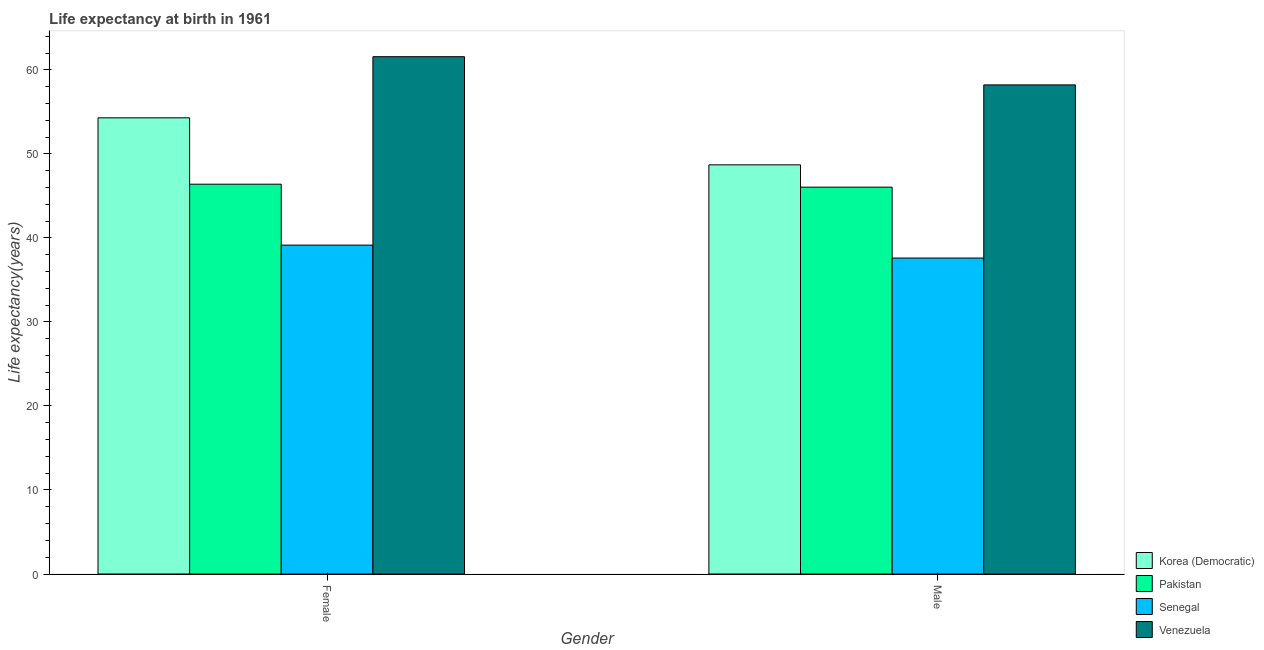Are the number of bars on each tick of the X-axis equal?
Your answer should be compact. Yes. How many bars are there on the 1st tick from the left?
Ensure brevity in your answer.  4. What is the life expectancy(male) in Pakistan?
Keep it short and to the point. 46.05. Across all countries, what is the maximum life expectancy(male)?
Make the answer very short. 58.23. Across all countries, what is the minimum life expectancy(male)?
Your response must be concise. 37.61. In which country was the life expectancy(female) maximum?
Your answer should be very brief. Venezuela. In which country was the life expectancy(female) minimum?
Make the answer very short. Senegal. What is the total life expectancy(female) in the graph?
Your answer should be very brief. 201.44. What is the difference between the life expectancy(male) in Pakistan and that in Senegal?
Make the answer very short. 8.44. What is the difference between the life expectancy(male) in Korea (Democratic) and the life expectancy(female) in Pakistan?
Give a very brief answer. 2.3. What is the average life expectancy(male) per country?
Offer a terse response. 47.65. What is the difference between the life expectancy(female) and life expectancy(male) in Korea (Democratic)?
Your response must be concise. 5.6. What is the ratio of the life expectancy(female) in Pakistan to that in Senegal?
Offer a very short reply. 1.19. Is the life expectancy(male) in Venezuela less than that in Pakistan?
Provide a succinct answer. No. In how many countries, is the life expectancy(female) greater than the average life expectancy(female) taken over all countries?
Your answer should be compact. 2. How many bars are there?
Offer a very short reply. 8. Are all the bars in the graph horizontal?
Your answer should be compact. No. How many countries are there in the graph?
Provide a succinct answer. 4. Are the values on the major ticks of Y-axis written in scientific E-notation?
Give a very brief answer. No. Where does the legend appear in the graph?
Offer a terse response. Bottom right. How are the legend labels stacked?
Provide a succinct answer. Vertical. What is the title of the graph?
Keep it short and to the point. Life expectancy at birth in 1961. What is the label or title of the X-axis?
Make the answer very short. Gender. What is the label or title of the Y-axis?
Your response must be concise. Life expectancy(years). What is the Life expectancy(years) of Korea (Democratic) in Female?
Give a very brief answer. 54.3. What is the Life expectancy(years) of Pakistan in Female?
Keep it short and to the point. 46.4. What is the Life expectancy(years) in Senegal in Female?
Give a very brief answer. 39.15. What is the Life expectancy(years) of Venezuela in Female?
Provide a short and direct response. 61.58. What is the Life expectancy(years) in Korea (Democratic) in Male?
Your response must be concise. 48.71. What is the Life expectancy(years) of Pakistan in Male?
Ensure brevity in your answer.  46.05. What is the Life expectancy(years) of Senegal in Male?
Your answer should be very brief. 37.61. What is the Life expectancy(years) in Venezuela in Male?
Keep it short and to the point. 58.23. Across all Gender, what is the maximum Life expectancy(years) in Korea (Democratic)?
Keep it short and to the point. 54.3. Across all Gender, what is the maximum Life expectancy(years) of Pakistan?
Give a very brief answer. 46.4. Across all Gender, what is the maximum Life expectancy(years) in Senegal?
Offer a very short reply. 39.15. Across all Gender, what is the maximum Life expectancy(years) in Venezuela?
Offer a terse response. 61.58. Across all Gender, what is the minimum Life expectancy(years) in Korea (Democratic)?
Give a very brief answer. 48.71. Across all Gender, what is the minimum Life expectancy(years) in Pakistan?
Provide a short and direct response. 46.05. Across all Gender, what is the minimum Life expectancy(years) in Senegal?
Provide a succinct answer. 37.61. Across all Gender, what is the minimum Life expectancy(years) of Venezuela?
Give a very brief answer. 58.23. What is the total Life expectancy(years) in Korea (Democratic) in the graph?
Your answer should be very brief. 103.01. What is the total Life expectancy(years) in Pakistan in the graph?
Your answer should be compact. 92.45. What is the total Life expectancy(years) in Senegal in the graph?
Provide a short and direct response. 76.76. What is the total Life expectancy(years) of Venezuela in the graph?
Provide a short and direct response. 119.81. What is the difference between the Life expectancy(years) in Korea (Democratic) in Female and that in Male?
Provide a succinct answer. 5.6. What is the difference between the Life expectancy(years) of Pakistan in Female and that in Male?
Provide a short and direct response. 0.35. What is the difference between the Life expectancy(years) of Senegal in Female and that in Male?
Your answer should be very brief. 1.54. What is the difference between the Life expectancy(years) in Venezuela in Female and that in Male?
Your answer should be compact. 3.36. What is the difference between the Life expectancy(years) of Korea (Democratic) in Female and the Life expectancy(years) of Pakistan in Male?
Offer a very short reply. 8.25. What is the difference between the Life expectancy(years) of Korea (Democratic) in Female and the Life expectancy(years) of Senegal in Male?
Your response must be concise. 16.69. What is the difference between the Life expectancy(years) of Korea (Democratic) in Female and the Life expectancy(years) of Venezuela in Male?
Offer a very short reply. -3.92. What is the difference between the Life expectancy(years) in Pakistan in Female and the Life expectancy(years) in Senegal in Male?
Your response must be concise. 8.79. What is the difference between the Life expectancy(years) in Pakistan in Female and the Life expectancy(years) in Venezuela in Male?
Your answer should be compact. -11.82. What is the difference between the Life expectancy(years) of Senegal in Female and the Life expectancy(years) of Venezuela in Male?
Provide a short and direct response. -19.07. What is the average Life expectancy(years) of Korea (Democratic) per Gender?
Your answer should be very brief. 51.51. What is the average Life expectancy(years) of Pakistan per Gender?
Keep it short and to the point. 46.23. What is the average Life expectancy(years) of Senegal per Gender?
Offer a terse response. 38.38. What is the average Life expectancy(years) of Venezuela per Gender?
Provide a succinct answer. 59.9. What is the difference between the Life expectancy(years) of Korea (Democratic) and Life expectancy(years) of Pakistan in Female?
Make the answer very short. 7.9. What is the difference between the Life expectancy(years) of Korea (Democratic) and Life expectancy(years) of Senegal in Female?
Make the answer very short. 15.15. What is the difference between the Life expectancy(years) of Korea (Democratic) and Life expectancy(years) of Venezuela in Female?
Ensure brevity in your answer.  -7.28. What is the difference between the Life expectancy(years) in Pakistan and Life expectancy(years) in Senegal in Female?
Give a very brief answer. 7.25. What is the difference between the Life expectancy(years) in Pakistan and Life expectancy(years) in Venezuela in Female?
Keep it short and to the point. -15.18. What is the difference between the Life expectancy(years) in Senegal and Life expectancy(years) in Venezuela in Female?
Give a very brief answer. -22.43. What is the difference between the Life expectancy(years) of Korea (Democratic) and Life expectancy(years) of Pakistan in Male?
Keep it short and to the point. 2.66. What is the difference between the Life expectancy(years) in Korea (Democratic) and Life expectancy(years) in Senegal in Male?
Offer a terse response. 11.1. What is the difference between the Life expectancy(years) in Korea (Democratic) and Life expectancy(years) in Venezuela in Male?
Your answer should be very brief. -9.52. What is the difference between the Life expectancy(years) of Pakistan and Life expectancy(years) of Senegal in Male?
Offer a terse response. 8.44. What is the difference between the Life expectancy(years) of Pakistan and Life expectancy(years) of Venezuela in Male?
Provide a succinct answer. -12.17. What is the difference between the Life expectancy(years) of Senegal and Life expectancy(years) of Venezuela in Male?
Offer a terse response. -20.61. What is the ratio of the Life expectancy(years) of Korea (Democratic) in Female to that in Male?
Provide a short and direct response. 1.11. What is the ratio of the Life expectancy(years) in Pakistan in Female to that in Male?
Offer a terse response. 1.01. What is the ratio of the Life expectancy(years) in Senegal in Female to that in Male?
Keep it short and to the point. 1.04. What is the ratio of the Life expectancy(years) in Venezuela in Female to that in Male?
Offer a terse response. 1.06. What is the difference between the highest and the second highest Life expectancy(years) in Korea (Democratic)?
Provide a short and direct response. 5.6. What is the difference between the highest and the second highest Life expectancy(years) of Pakistan?
Keep it short and to the point. 0.35. What is the difference between the highest and the second highest Life expectancy(years) in Senegal?
Your response must be concise. 1.54. What is the difference between the highest and the second highest Life expectancy(years) in Venezuela?
Offer a terse response. 3.36. What is the difference between the highest and the lowest Life expectancy(years) in Korea (Democratic)?
Your response must be concise. 5.6. What is the difference between the highest and the lowest Life expectancy(years) of Pakistan?
Give a very brief answer. 0.35. What is the difference between the highest and the lowest Life expectancy(years) of Senegal?
Provide a short and direct response. 1.54. What is the difference between the highest and the lowest Life expectancy(years) of Venezuela?
Provide a succinct answer. 3.36. 